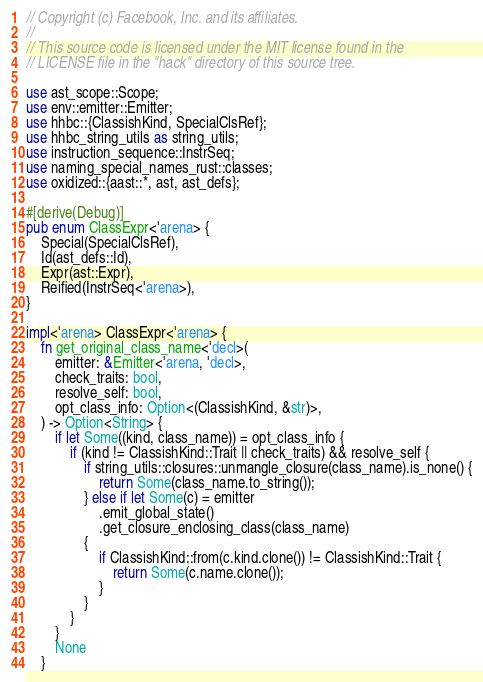Convert code to text. <code><loc_0><loc_0><loc_500><loc_500><_Rust_>// Copyright (c) Facebook, Inc. and its affiliates.
//
// This source code is licensed under the MIT license found in the
// LICENSE file in the "hack" directory of this source tree.

use ast_scope::Scope;
use env::emitter::Emitter;
use hhbc::{ClassishKind, SpecialClsRef};
use hhbc_string_utils as string_utils;
use instruction_sequence::InstrSeq;
use naming_special_names_rust::classes;
use oxidized::{aast::*, ast, ast_defs};

#[derive(Debug)]
pub enum ClassExpr<'arena> {
    Special(SpecialClsRef),
    Id(ast_defs::Id),
    Expr(ast::Expr),
    Reified(InstrSeq<'arena>),
}

impl<'arena> ClassExpr<'arena> {
    fn get_original_class_name<'decl>(
        emitter: &Emitter<'arena, 'decl>,
        check_traits: bool,
        resolve_self: bool,
        opt_class_info: Option<(ClassishKind, &str)>,
    ) -> Option<String> {
        if let Some((kind, class_name)) = opt_class_info {
            if (kind != ClassishKind::Trait || check_traits) && resolve_self {
                if string_utils::closures::unmangle_closure(class_name).is_none() {
                    return Some(class_name.to_string());
                } else if let Some(c) = emitter
                    .emit_global_state()
                    .get_closure_enclosing_class(class_name)
                {
                    if ClassishKind::from(c.kind.clone()) != ClassishKind::Trait {
                        return Some(c.name.clone());
                    }
                }
            }
        }
        None
    }
</code> 